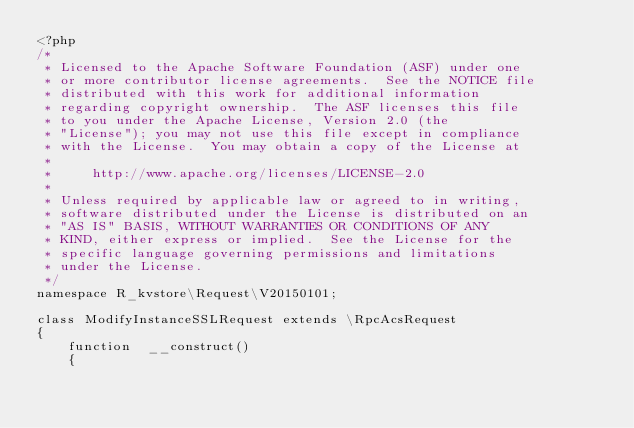Convert code to text. <code><loc_0><loc_0><loc_500><loc_500><_PHP_><?php
/*
 * Licensed to the Apache Software Foundation (ASF) under one
 * or more contributor license agreements.  See the NOTICE file
 * distributed with this work for additional information
 * regarding copyright ownership.  The ASF licenses this file
 * to you under the Apache License, Version 2.0 (the
 * "License"); you may not use this file except in compliance
 * with the License.  You may obtain a copy of the License at
 *
 *     http://www.apache.org/licenses/LICENSE-2.0
 *
 * Unless required by applicable law or agreed to in writing,
 * software distributed under the License is distributed on an
 * "AS IS" BASIS, WITHOUT WARRANTIES OR CONDITIONS OF ANY
 * KIND, either express or implied.  See the License for the
 * specific language governing permissions and limitations
 * under the License.
 */
namespace R_kvstore\Request\V20150101;

class ModifyInstanceSSLRequest extends \RpcAcsRequest
{
	function  __construct()
	{</code> 